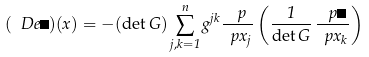<formula> <loc_0><loc_0><loc_500><loc_500>( \ D e \psi ) ( x ) = - ( \det G ) \sum _ { j , k = 1 } ^ { n } g ^ { j k } \frac { \ p } { \ p x _ { j } } \left ( \frac { 1 } { \det G } \, \frac { \ p \psi } { \ p x _ { k } } \right )</formula> 